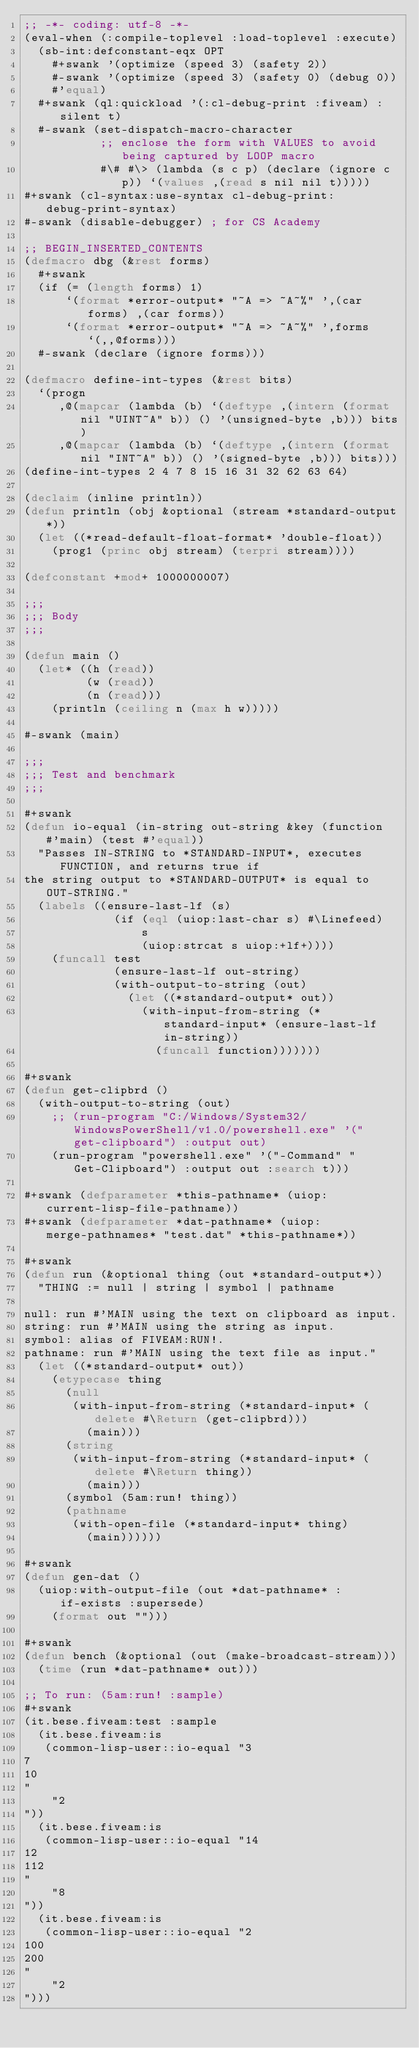Convert code to text. <code><loc_0><loc_0><loc_500><loc_500><_Lisp_>;; -*- coding: utf-8 -*-
(eval-when (:compile-toplevel :load-toplevel :execute)
  (sb-int:defconstant-eqx OPT
    #+swank '(optimize (speed 3) (safety 2))
    #-swank '(optimize (speed 3) (safety 0) (debug 0))
    #'equal)
  #+swank (ql:quickload '(:cl-debug-print :fiveam) :silent t)
  #-swank (set-dispatch-macro-character
           ;; enclose the form with VALUES to avoid being captured by LOOP macro
           #\# #\> (lambda (s c p) (declare (ignore c p)) `(values ,(read s nil nil t)))))
#+swank (cl-syntax:use-syntax cl-debug-print:debug-print-syntax)
#-swank (disable-debugger) ; for CS Academy

;; BEGIN_INSERTED_CONTENTS
(defmacro dbg (&rest forms)
  #+swank
  (if (= (length forms) 1)
      `(format *error-output* "~A => ~A~%" ',(car forms) ,(car forms))
      `(format *error-output* "~A => ~A~%" ',forms `(,,@forms)))
  #-swank (declare (ignore forms)))

(defmacro define-int-types (&rest bits)
  `(progn
     ,@(mapcar (lambda (b) `(deftype ,(intern (format nil "UINT~A" b)) () '(unsigned-byte ,b))) bits)
     ,@(mapcar (lambda (b) `(deftype ,(intern (format nil "INT~A" b)) () '(signed-byte ,b))) bits)))
(define-int-types 2 4 7 8 15 16 31 32 62 63 64)

(declaim (inline println))
(defun println (obj &optional (stream *standard-output*))
  (let ((*read-default-float-format* 'double-float))
    (prog1 (princ obj stream) (terpri stream))))

(defconstant +mod+ 1000000007)

;;;
;;; Body
;;;

(defun main ()
  (let* ((h (read))
         (w (read))
         (n (read)))
    (println (ceiling n (max h w)))))

#-swank (main)

;;;
;;; Test and benchmark
;;;

#+swank
(defun io-equal (in-string out-string &key (function #'main) (test #'equal))
  "Passes IN-STRING to *STANDARD-INPUT*, executes FUNCTION, and returns true if
the string output to *STANDARD-OUTPUT* is equal to OUT-STRING."
  (labels ((ensure-last-lf (s)
             (if (eql (uiop:last-char s) #\Linefeed)
                 s
                 (uiop:strcat s uiop:+lf+))))
    (funcall test
             (ensure-last-lf out-string)
             (with-output-to-string (out)
               (let ((*standard-output* out))
                 (with-input-from-string (*standard-input* (ensure-last-lf in-string))
                   (funcall function)))))))

#+swank
(defun get-clipbrd ()
  (with-output-to-string (out)
    ;; (run-program "C:/Windows/System32/WindowsPowerShell/v1.0/powershell.exe" '("get-clipboard") :output out)
    (run-program "powershell.exe" '("-Command" "Get-Clipboard") :output out :search t)))

#+swank (defparameter *this-pathname* (uiop:current-lisp-file-pathname))
#+swank (defparameter *dat-pathname* (uiop:merge-pathnames* "test.dat" *this-pathname*))

#+swank
(defun run (&optional thing (out *standard-output*))
  "THING := null | string | symbol | pathname

null: run #'MAIN using the text on clipboard as input.
string: run #'MAIN using the string as input.
symbol: alias of FIVEAM:RUN!.
pathname: run #'MAIN using the text file as input."
  (let ((*standard-output* out))
    (etypecase thing
      (null
       (with-input-from-string (*standard-input* (delete #\Return (get-clipbrd)))
         (main)))
      (string
       (with-input-from-string (*standard-input* (delete #\Return thing))
         (main)))
      (symbol (5am:run! thing))
      (pathname
       (with-open-file (*standard-input* thing)
         (main))))))

#+swank
(defun gen-dat ()
  (uiop:with-output-file (out *dat-pathname* :if-exists :supersede)
    (format out "")))

#+swank
(defun bench (&optional (out (make-broadcast-stream)))
  (time (run *dat-pathname* out)))

;; To run: (5am:run! :sample)
#+swank
(it.bese.fiveam:test :sample
  (it.bese.fiveam:is
   (common-lisp-user::io-equal "3
7
10
"
    "2
"))
  (it.bese.fiveam:is
   (common-lisp-user::io-equal "14
12
112
"
    "8
"))
  (it.bese.fiveam:is
   (common-lisp-user::io-equal "2
100
200
"
    "2
")))
</code> 